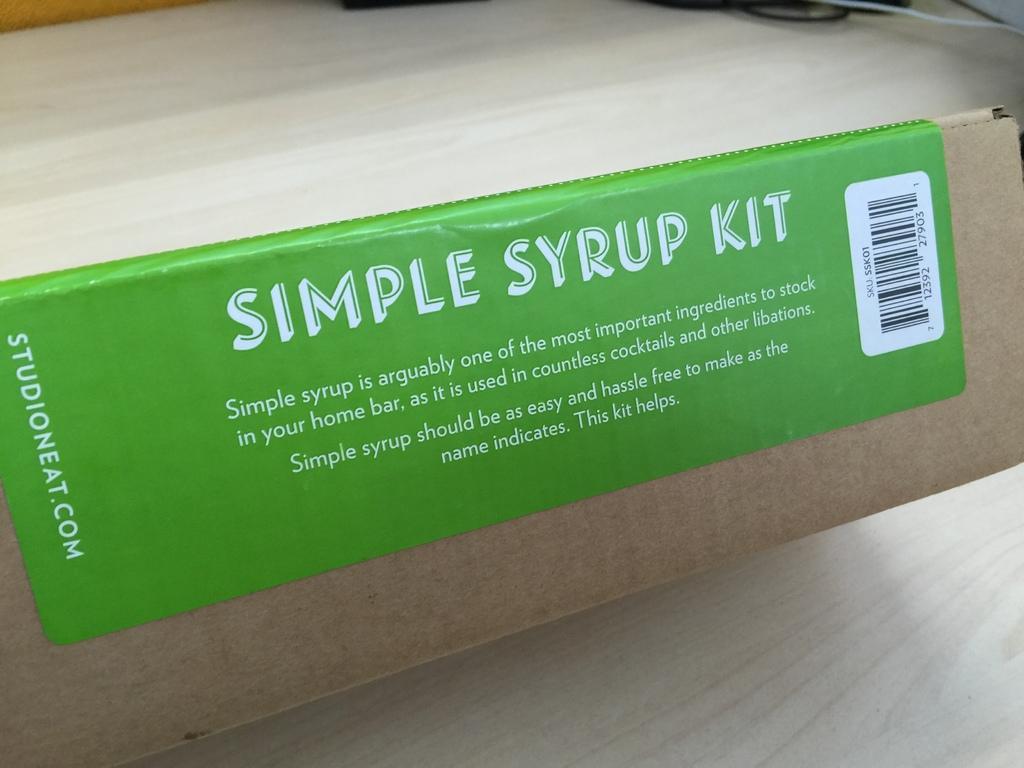In one or two sentences, can you explain what this image depicts? In this image I can see a green sticker attached on a carton. 